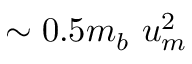Convert formula to latex. <formula><loc_0><loc_0><loc_500><loc_500>\sim 0 . 5 m _ { b } \ u _ { m } ^ { 2 }</formula> 